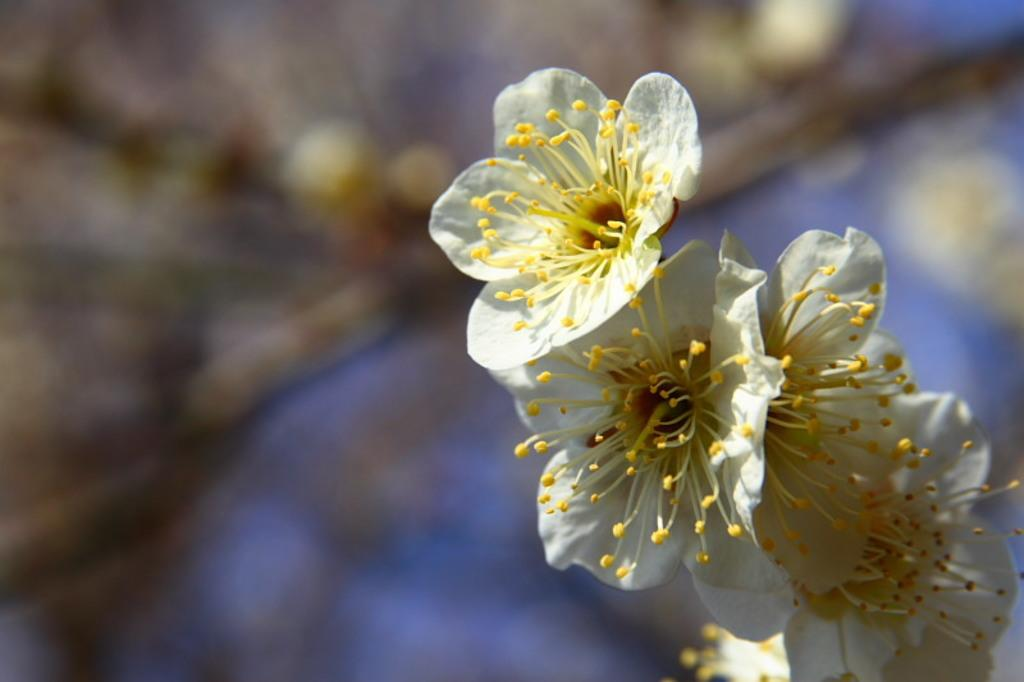What type of flowers can be seen on the tree in the image? There are white color flowers on a tree in the image. On which side of the image are the flowers located? The flowers are on the right side of the image. Can you describe the background of the image? The background of the image is blurred. What type of toothbrush is hanging from the tree in the image? There is no toothbrush present in the image; it features white color flowers on a tree. 